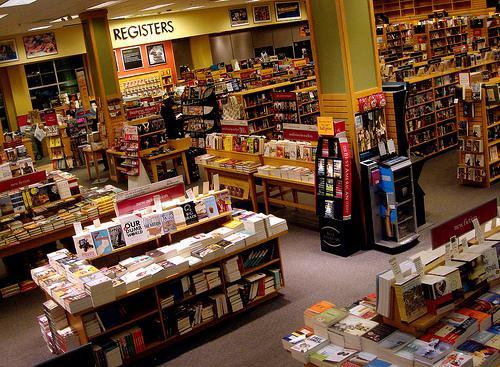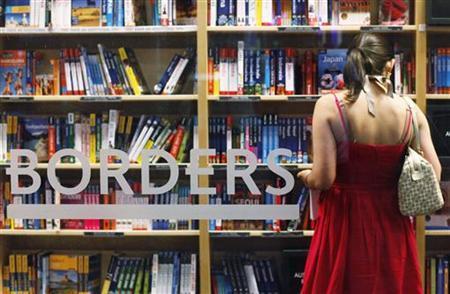The first image is the image on the left, the second image is the image on the right. Given the left and right images, does the statement "In at least one image there is a single long haired girl looking at book on a brown bookshelf." hold true? Answer yes or no. Yes. The first image is the image on the left, the second image is the image on the right. For the images displayed, is the sentence "There is one person in the bookstore looking at books in one of the images." factually correct? Answer yes or no. Yes. 